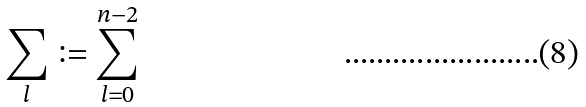Convert formula to latex. <formula><loc_0><loc_0><loc_500><loc_500>\sum _ { l } \vcentcolon = \sum _ { l = 0 } ^ { n - 2 }</formula> 